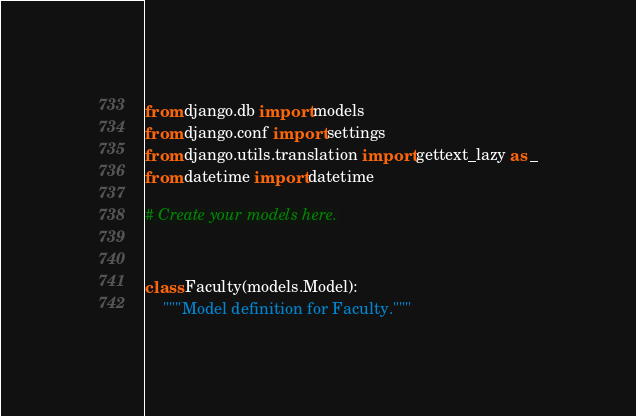Convert code to text. <code><loc_0><loc_0><loc_500><loc_500><_Python_>from django.db import models
from django.conf import settings
from django.utils.translation import gettext_lazy as _
from datetime import datetime

# Create your models here.


class Faculty(models.Model):
    """Model definition for Faculty."""
</code> 